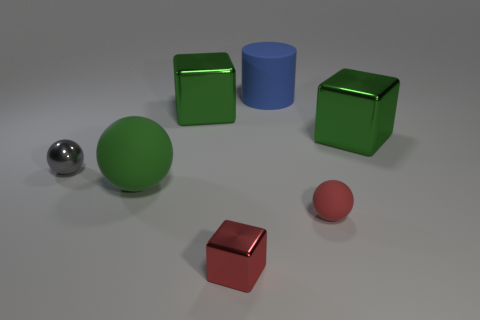Add 3 small gray spheres. How many objects exist? 10 Subtract all cubes. How many objects are left? 4 Subtract all large red shiny cylinders. Subtract all large green cubes. How many objects are left? 5 Add 6 big matte cylinders. How many big matte cylinders are left? 7 Add 4 small green cylinders. How many small green cylinders exist? 4 Subtract 0 gray cylinders. How many objects are left? 7 